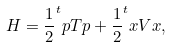Convert formula to latex. <formula><loc_0><loc_0><loc_500><loc_500>H = \frac { 1 } { 2 } ^ { t } { p } T { p } + \frac { 1 } { 2 } ^ { t } { x } V { x } ,</formula> 